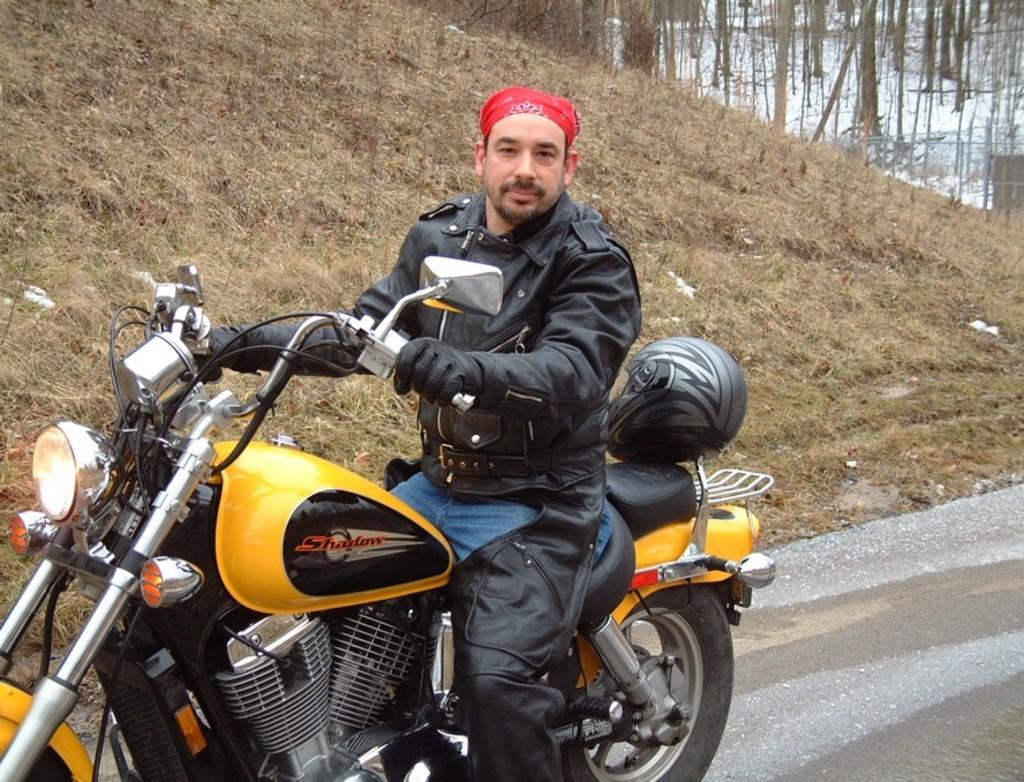Describe this image in one or two sentences. This man wore black jacket, holding handle and sitting on this motor bike. Far there are number of trees. On this motorbike there is a helmet. 